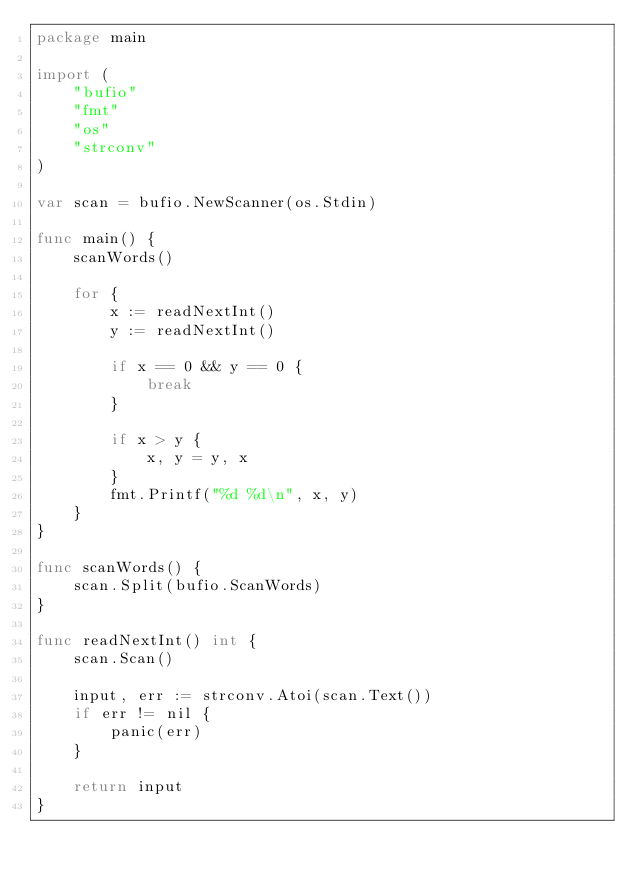Convert code to text. <code><loc_0><loc_0><loc_500><loc_500><_Go_>package main

import (
	"bufio"
	"fmt"
	"os"
	"strconv"
)

var scan = bufio.NewScanner(os.Stdin)

func main() {
	scanWords()

	for {
		x := readNextInt()
		y := readNextInt()

		if x == 0 && y == 0 {
			break
		}

		if x > y {
			x, y = y, x
		}
		fmt.Printf("%d %d\n", x, y)
	}
}

func scanWords() {
	scan.Split(bufio.ScanWords)
}

func readNextInt() int {
	scan.Scan()

	input, err := strconv.Atoi(scan.Text())
	if err != nil {
		panic(err)
	}

	return input
}

</code> 